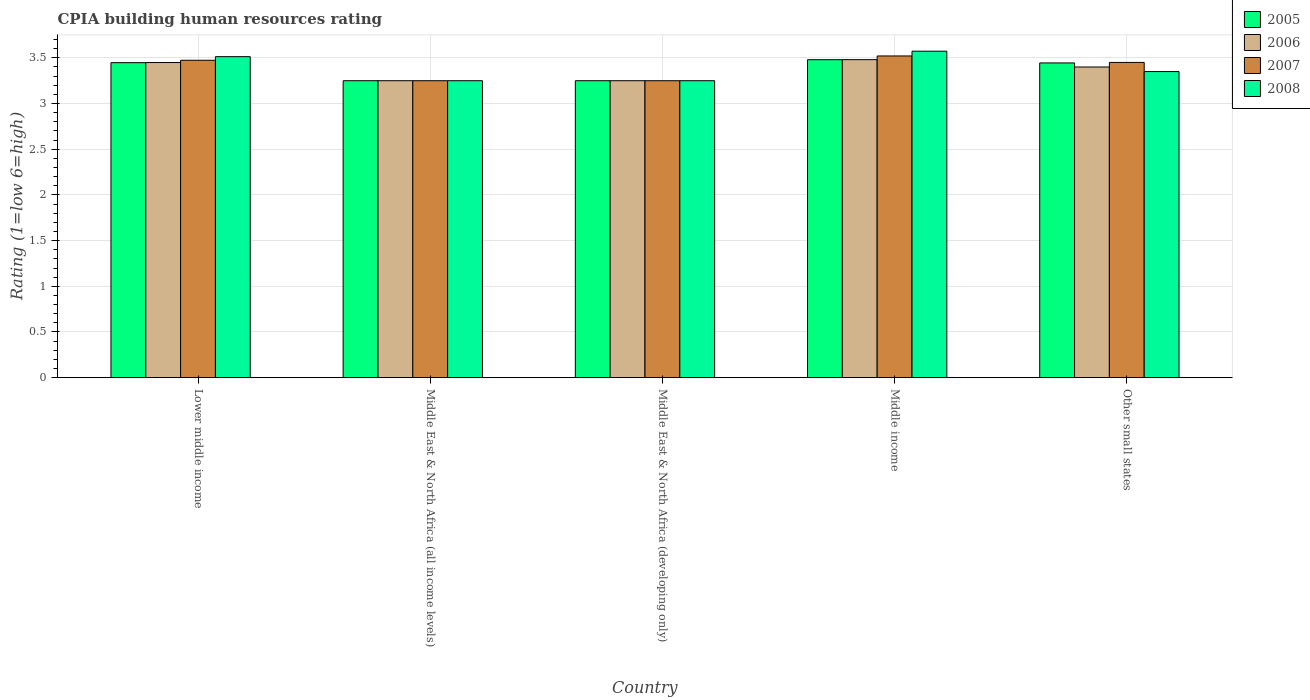How many different coloured bars are there?
Provide a short and direct response. 4. How many groups of bars are there?
Provide a succinct answer. 5. Are the number of bars per tick equal to the number of legend labels?
Offer a terse response. Yes. Are the number of bars on each tick of the X-axis equal?
Ensure brevity in your answer.  Yes. How many bars are there on the 4th tick from the left?
Your response must be concise. 4. How many bars are there on the 1st tick from the right?
Your response must be concise. 4. What is the label of the 1st group of bars from the left?
Give a very brief answer. Lower middle income. What is the CPIA rating in 2005 in Middle income?
Make the answer very short. 3.48. Across all countries, what is the maximum CPIA rating in 2007?
Make the answer very short. 3.52. Across all countries, what is the minimum CPIA rating in 2008?
Your response must be concise. 3.25. In which country was the CPIA rating in 2006 maximum?
Ensure brevity in your answer.  Middle income. In which country was the CPIA rating in 2006 minimum?
Your answer should be very brief. Middle East & North Africa (all income levels). What is the total CPIA rating in 2005 in the graph?
Ensure brevity in your answer.  16.87. What is the difference between the CPIA rating in 2005 in Middle income and that in Other small states?
Provide a short and direct response. 0.04. What is the difference between the CPIA rating in 2008 in Other small states and the CPIA rating in 2006 in Middle income?
Offer a very short reply. -0.13. What is the average CPIA rating in 2006 per country?
Give a very brief answer. 3.37. What is the difference between the CPIA rating of/in 2008 and CPIA rating of/in 2005 in Lower middle income?
Give a very brief answer. 0.07. What is the ratio of the CPIA rating in 2006 in Lower middle income to that in Middle East & North Africa (developing only)?
Your answer should be very brief. 1.06. Is the CPIA rating in 2008 in Middle East & North Africa (all income levels) less than that in Other small states?
Your answer should be compact. Yes. Is the difference between the CPIA rating in 2008 in Lower middle income and Middle East & North Africa (developing only) greater than the difference between the CPIA rating in 2005 in Lower middle income and Middle East & North Africa (developing only)?
Your response must be concise. Yes. What is the difference between the highest and the second highest CPIA rating in 2006?
Offer a very short reply. -0.03. What is the difference between the highest and the lowest CPIA rating in 2007?
Give a very brief answer. 0.27. What does the 1st bar from the right in Middle income represents?
Your answer should be very brief. 2008. How many bars are there?
Your answer should be compact. 20. Are all the bars in the graph horizontal?
Keep it short and to the point. No. How many countries are there in the graph?
Your answer should be very brief. 5. What is the difference between two consecutive major ticks on the Y-axis?
Give a very brief answer. 0.5. Are the values on the major ticks of Y-axis written in scientific E-notation?
Make the answer very short. No. Does the graph contain any zero values?
Your answer should be compact. No. Does the graph contain grids?
Your response must be concise. Yes. Where does the legend appear in the graph?
Your response must be concise. Top right. How many legend labels are there?
Provide a short and direct response. 4. How are the legend labels stacked?
Offer a terse response. Vertical. What is the title of the graph?
Your answer should be very brief. CPIA building human resources rating. What is the label or title of the Y-axis?
Your answer should be very brief. Rating (1=low 6=high). What is the Rating (1=low 6=high) of 2005 in Lower middle income?
Provide a short and direct response. 3.45. What is the Rating (1=low 6=high) of 2006 in Lower middle income?
Offer a terse response. 3.45. What is the Rating (1=low 6=high) in 2007 in Lower middle income?
Ensure brevity in your answer.  3.47. What is the Rating (1=low 6=high) in 2008 in Lower middle income?
Give a very brief answer. 3.51. What is the Rating (1=low 6=high) in 2005 in Middle East & North Africa (all income levels)?
Your answer should be very brief. 3.25. What is the Rating (1=low 6=high) in 2007 in Middle East & North Africa (all income levels)?
Keep it short and to the point. 3.25. What is the Rating (1=low 6=high) of 2008 in Middle East & North Africa (all income levels)?
Ensure brevity in your answer.  3.25. What is the Rating (1=low 6=high) in 2007 in Middle East & North Africa (developing only)?
Offer a terse response. 3.25. What is the Rating (1=low 6=high) of 2005 in Middle income?
Make the answer very short. 3.48. What is the Rating (1=low 6=high) of 2006 in Middle income?
Give a very brief answer. 3.48. What is the Rating (1=low 6=high) in 2007 in Middle income?
Your answer should be very brief. 3.52. What is the Rating (1=low 6=high) of 2008 in Middle income?
Provide a succinct answer. 3.57. What is the Rating (1=low 6=high) in 2005 in Other small states?
Offer a very short reply. 3.44. What is the Rating (1=low 6=high) of 2007 in Other small states?
Your answer should be compact. 3.45. What is the Rating (1=low 6=high) in 2008 in Other small states?
Ensure brevity in your answer.  3.35. Across all countries, what is the maximum Rating (1=low 6=high) in 2005?
Offer a very short reply. 3.48. Across all countries, what is the maximum Rating (1=low 6=high) in 2006?
Your answer should be compact. 3.48. Across all countries, what is the maximum Rating (1=low 6=high) in 2007?
Offer a very short reply. 3.52. Across all countries, what is the maximum Rating (1=low 6=high) of 2008?
Offer a very short reply. 3.57. Across all countries, what is the minimum Rating (1=low 6=high) in 2007?
Provide a short and direct response. 3.25. Across all countries, what is the minimum Rating (1=low 6=high) of 2008?
Offer a very short reply. 3.25. What is the total Rating (1=low 6=high) of 2005 in the graph?
Your response must be concise. 16.87. What is the total Rating (1=low 6=high) of 2006 in the graph?
Make the answer very short. 16.83. What is the total Rating (1=low 6=high) in 2007 in the graph?
Offer a terse response. 16.94. What is the total Rating (1=low 6=high) of 2008 in the graph?
Make the answer very short. 16.94. What is the difference between the Rating (1=low 6=high) of 2005 in Lower middle income and that in Middle East & North Africa (all income levels)?
Your answer should be very brief. 0.2. What is the difference between the Rating (1=low 6=high) of 2006 in Lower middle income and that in Middle East & North Africa (all income levels)?
Your answer should be very brief. 0.2. What is the difference between the Rating (1=low 6=high) of 2007 in Lower middle income and that in Middle East & North Africa (all income levels)?
Your response must be concise. 0.22. What is the difference between the Rating (1=low 6=high) of 2008 in Lower middle income and that in Middle East & North Africa (all income levels)?
Offer a very short reply. 0.26. What is the difference between the Rating (1=low 6=high) in 2005 in Lower middle income and that in Middle East & North Africa (developing only)?
Ensure brevity in your answer.  0.2. What is the difference between the Rating (1=low 6=high) in 2006 in Lower middle income and that in Middle East & North Africa (developing only)?
Your response must be concise. 0.2. What is the difference between the Rating (1=low 6=high) in 2007 in Lower middle income and that in Middle East & North Africa (developing only)?
Offer a terse response. 0.22. What is the difference between the Rating (1=low 6=high) of 2008 in Lower middle income and that in Middle East & North Africa (developing only)?
Provide a short and direct response. 0.26. What is the difference between the Rating (1=low 6=high) of 2005 in Lower middle income and that in Middle income?
Make the answer very short. -0.03. What is the difference between the Rating (1=low 6=high) in 2006 in Lower middle income and that in Middle income?
Offer a terse response. -0.03. What is the difference between the Rating (1=low 6=high) in 2007 in Lower middle income and that in Middle income?
Make the answer very short. -0.05. What is the difference between the Rating (1=low 6=high) of 2008 in Lower middle income and that in Middle income?
Make the answer very short. -0.06. What is the difference between the Rating (1=low 6=high) in 2005 in Lower middle income and that in Other small states?
Your answer should be compact. 0. What is the difference between the Rating (1=low 6=high) of 2006 in Lower middle income and that in Other small states?
Make the answer very short. 0.05. What is the difference between the Rating (1=low 6=high) in 2007 in Lower middle income and that in Other small states?
Offer a very short reply. 0.02. What is the difference between the Rating (1=low 6=high) of 2008 in Lower middle income and that in Other small states?
Offer a very short reply. 0.16. What is the difference between the Rating (1=low 6=high) in 2005 in Middle East & North Africa (all income levels) and that in Middle East & North Africa (developing only)?
Your answer should be compact. 0. What is the difference between the Rating (1=low 6=high) in 2007 in Middle East & North Africa (all income levels) and that in Middle East & North Africa (developing only)?
Your answer should be compact. 0. What is the difference between the Rating (1=low 6=high) of 2008 in Middle East & North Africa (all income levels) and that in Middle East & North Africa (developing only)?
Provide a short and direct response. 0. What is the difference between the Rating (1=low 6=high) in 2005 in Middle East & North Africa (all income levels) and that in Middle income?
Your answer should be compact. -0.23. What is the difference between the Rating (1=low 6=high) in 2006 in Middle East & North Africa (all income levels) and that in Middle income?
Ensure brevity in your answer.  -0.23. What is the difference between the Rating (1=low 6=high) in 2007 in Middle East & North Africa (all income levels) and that in Middle income?
Offer a very short reply. -0.27. What is the difference between the Rating (1=low 6=high) in 2008 in Middle East & North Africa (all income levels) and that in Middle income?
Ensure brevity in your answer.  -0.32. What is the difference between the Rating (1=low 6=high) in 2005 in Middle East & North Africa (all income levels) and that in Other small states?
Keep it short and to the point. -0.19. What is the difference between the Rating (1=low 6=high) in 2006 in Middle East & North Africa (all income levels) and that in Other small states?
Offer a terse response. -0.15. What is the difference between the Rating (1=low 6=high) of 2007 in Middle East & North Africa (all income levels) and that in Other small states?
Your response must be concise. -0.2. What is the difference between the Rating (1=low 6=high) in 2005 in Middle East & North Africa (developing only) and that in Middle income?
Ensure brevity in your answer.  -0.23. What is the difference between the Rating (1=low 6=high) in 2006 in Middle East & North Africa (developing only) and that in Middle income?
Give a very brief answer. -0.23. What is the difference between the Rating (1=low 6=high) in 2007 in Middle East & North Africa (developing only) and that in Middle income?
Make the answer very short. -0.27. What is the difference between the Rating (1=low 6=high) in 2008 in Middle East & North Africa (developing only) and that in Middle income?
Offer a terse response. -0.32. What is the difference between the Rating (1=low 6=high) in 2005 in Middle East & North Africa (developing only) and that in Other small states?
Provide a short and direct response. -0.19. What is the difference between the Rating (1=low 6=high) in 2005 in Middle income and that in Other small states?
Your answer should be compact. 0.04. What is the difference between the Rating (1=low 6=high) in 2006 in Middle income and that in Other small states?
Make the answer very short. 0.08. What is the difference between the Rating (1=low 6=high) of 2007 in Middle income and that in Other small states?
Your answer should be compact. 0.07. What is the difference between the Rating (1=low 6=high) in 2008 in Middle income and that in Other small states?
Give a very brief answer. 0.22. What is the difference between the Rating (1=low 6=high) of 2005 in Lower middle income and the Rating (1=low 6=high) of 2006 in Middle East & North Africa (all income levels)?
Offer a very short reply. 0.2. What is the difference between the Rating (1=low 6=high) in 2005 in Lower middle income and the Rating (1=low 6=high) in 2007 in Middle East & North Africa (all income levels)?
Keep it short and to the point. 0.2. What is the difference between the Rating (1=low 6=high) of 2005 in Lower middle income and the Rating (1=low 6=high) of 2008 in Middle East & North Africa (all income levels)?
Offer a terse response. 0.2. What is the difference between the Rating (1=low 6=high) in 2006 in Lower middle income and the Rating (1=low 6=high) in 2007 in Middle East & North Africa (all income levels)?
Provide a short and direct response. 0.2. What is the difference between the Rating (1=low 6=high) in 2006 in Lower middle income and the Rating (1=low 6=high) in 2008 in Middle East & North Africa (all income levels)?
Ensure brevity in your answer.  0.2. What is the difference between the Rating (1=low 6=high) of 2007 in Lower middle income and the Rating (1=low 6=high) of 2008 in Middle East & North Africa (all income levels)?
Your response must be concise. 0.22. What is the difference between the Rating (1=low 6=high) in 2005 in Lower middle income and the Rating (1=low 6=high) in 2006 in Middle East & North Africa (developing only)?
Keep it short and to the point. 0.2. What is the difference between the Rating (1=low 6=high) in 2005 in Lower middle income and the Rating (1=low 6=high) in 2007 in Middle East & North Africa (developing only)?
Offer a terse response. 0.2. What is the difference between the Rating (1=low 6=high) of 2005 in Lower middle income and the Rating (1=low 6=high) of 2008 in Middle East & North Africa (developing only)?
Make the answer very short. 0.2. What is the difference between the Rating (1=low 6=high) in 2006 in Lower middle income and the Rating (1=low 6=high) in 2007 in Middle East & North Africa (developing only)?
Your answer should be very brief. 0.2. What is the difference between the Rating (1=low 6=high) of 2006 in Lower middle income and the Rating (1=low 6=high) of 2008 in Middle East & North Africa (developing only)?
Ensure brevity in your answer.  0.2. What is the difference between the Rating (1=low 6=high) in 2007 in Lower middle income and the Rating (1=low 6=high) in 2008 in Middle East & North Africa (developing only)?
Provide a short and direct response. 0.22. What is the difference between the Rating (1=low 6=high) of 2005 in Lower middle income and the Rating (1=low 6=high) of 2006 in Middle income?
Offer a very short reply. -0.03. What is the difference between the Rating (1=low 6=high) of 2005 in Lower middle income and the Rating (1=low 6=high) of 2007 in Middle income?
Your answer should be very brief. -0.07. What is the difference between the Rating (1=low 6=high) in 2005 in Lower middle income and the Rating (1=low 6=high) in 2008 in Middle income?
Keep it short and to the point. -0.13. What is the difference between the Rating (1=low 6=high) in 2006 in Lower middle income and the Rating (1=low 6=high) in 2007 in Middle income?
Your answer should be compact. -0.07. What is the difference between the Rating (1=low 6=high) in 2006 in Lower middle income and the Rating (1=low 6=high) in 2008 in Middle income?
Give a very brief answer. -0.12. What is the difference between the Rating (1=low 6=high) of 2007 in Lower middle income and the Rating (1=low 6=high) of 2008 in Middle income?
Your answer should be very brief. -0.1. What is the difference between the Rating (1=low 6=high) of 2005 in Lower middle income and the Rating (1=low 6=high) of 2006 in Other small states?
Provide a succinct answer. 0.05. What is the difference between the Rating (1=low 6=high) in 2005 in Lower middle income and the Rating (1=low 6=high) in 2007 in Other small states?
Your answer should be compact. -0. What is the difference between the Rating (1=low 6=high) of 2005 in Lower middle income and the Rating (1=low 6=high) of 2008 in Other small states?
Offer a very short reply. 0.1. What is the difference between the Rating (1=low 6=high) in 2006 in Lower middle income and the Rating (1=low 6=high) in 2007 in Other small states?
Give a very brief answer. -0. What is the difference between the Rating (1=low 6=high) in 2006 in Lower middle income and the Rating (1=low 6=high) in 2008 in Other small states?
Your answer should be compact. 0.1. What is the difference between the Rating (1=low 6=high) of 2007 in Lower middle income and the Rating (1=low 6=high) of 2008 in Other small states?
Your answer should be very brief. 0.12. What is the difference between the Rating (1=low 6=high) in 2006 in Middle East & North Africa (all income levels) and the Rating (1=low 6=high) in 2007 in Middle East & North Africa (developing only)?
Your response must be concise. 0. What is the difference between the Rating (1=low 6=high) of 2005 in Middle East & North Africa (all income levels) and the Rating (1=low 6=high) of 2006 in Middle income?
Keep it short and to the point. -0.23. What is the difference between the Rating (1=low 6=high) in 2005 in Middle East & North Africa (all income levels) and the Rating (1=low 6=high) in 2007 in Middle income?
Provide a succinct answer. -0.27. What is the difference between the Rating (1=low 6=high) in 2005 in Middle East & North Africa (all income levels) and the Rating (1=low 6=high) in 2008 in Middle income?
Keep it short and to the point. -0.32. What is the difference between the Rating (1=low 6=high) of 2006 in Middle East & North Africa (all income levels) and the Rating (1=low 6=high) of 2007 in Middle income?
Provide a short and direct response. -0.27. What is the difference between the Rating (1=low 6=high) of 2006 in Middle East & North Africa (all income levels) and the Rating (1=low 6=high) of 2008 in Middle income?
Offer a very short reply. -0.32. What is the difference between the Rating (1=low 6=high) of 2007 in Middle East & North Africa (all income levels) and the Rating (1=low 6=high) of 2008 in Middle income?
Give a very brief answer. -0.32. What is the difference between the Rating (1=low 6=high) of 2005 in Middle East & North Africa (all income levels) and the Rating (1=low 6=high) of 2006 in Other small states?
Make the answer very short. -0.15. What is the difference between the Rating (1=low 6=high) of 2005 in Middle East & North Africa (all income levels) and the Rating (1=low 6=high) of 2008 in Other small states?
Keep it short and to the point. -0.1. What is the difference between the Rating (1=low 6=high) in 2006 in Middle East & North Africa (all income levels) and the Rating (1=low 6=high) in 2007 in Other small states?
Keep it short and to the point. -0.2. What is the difference between the Rating (1=low 6=high) of 2006 in Middle East & North Africa (all income levels) and the Rating (1=low 6=high) of 2008 in Other small states?
Provide a succinct answer. -0.1. What is the difference between the Rating (1=low 6=high) of 2005 in Middle East & North Africa (developing only) and the Rating (1=low 6=high) of 2006 in Middle income?
Provide a short and direct response. -0.23. What is the difference between the Rating (1=low 6=high) in 2005 in Middle East & North Africa (developing only) and the Rating (1=low 6=high) in 2007 in Middle income?
Your answer should be very brief. -0.27. What is the difference between the Rating (1=low 6=high) of 2005 in Middle East & North Africa (developing only) and the Rating (1=low 6=high) of 2008 in Middle income?
Ensure brevity in your answer.  -0.32. What is the difference between the Rating (1=low 6=high) in 2006 in Middle East & North Africa (developing only) and the Rating (1=low 6=high) in 2007 in Middle income?
Provide a succinct answer. -0.27. What is the difference between the Rating (1=low 6=high) in 2006 in Middle East & North Africa (developing only) and the Rating (1=low 6=high) in 2008 in Middle income?
Your answer should be compact. -0.32. What is the difference between the Rating (1=low 6=high) in 2007 in Middle East & North Africa (developing only) and the Rating (1=low 6=high) in 2008 in Middle income?
Provide a succinct answer. -0.32. What is the difference between the Rating (1=low 6=high) in 2005 in Middle East & North Africa (developing only) and the Rating (1=low 6=high) in 2006 in Other small states?
Your response must be concise. -0.15. What is the difference between the Rating (1=low 6=high) of 2005 in Middle East & North Africa (developing only) and the Rating (1=low 6=high) of 2007 in Other small states?
Make the answer very short. -0.2. What is the difference between the Rating (1=low 6=high) of 2005 in Middle income and the Rating (1=low 6=high) of 2006 in Other small states?
Offer a terse response. 0.08. What is the difference between the Rating (1=low 6=high) of 2005 in Middle income and the Rating (1=low 6=high) of 2007 in Other small states?
Offer a terse response. 0.03. What is the difference between the Rating (1=low 6=high) in 2005 in Middle income and the Rating (1=low 6=high) in 2008 in Other small states?
Offer a terse response. 0.13. What is the difference between the Rating (1=low 6=high) of 2006 in Middle income and the Rating (1=low 6=high) of 2007 in Other small states?
Make the answer very short. 0.03. What is the difference between the Rating (1=low 6=high) of 2006 in Middle income and the Rating (1=low 6=high) of 2008 in Other small states?
Your answer should be very brief. 0.13. What is the difference between the Rating (1=low 6=high) in 2007 in Middle income and the Rating (1=low 6=high) in 2008 in Other small states?
Your response must be concise. 0.17. What is the average Rating (1=low 6=high) of 2005 per country?
Provide a short and direct response. 3.37. What is the average Rating (1=low 6=high) of 2006 per country?
Offer a terse response. 3.37. What is the average Rating (1=low 6=high) in 2007 per country?
Your answer should be very brief. 3.39. What is the average Rating (1=low 6=high) of 2008 per country?
Keep it short and to the point. 3.39. What is the difference between the Rating (1=low 6=high) of 2005 and Rating (1=low 6=high) of 2006 in Lower middle income?
Your answer should be very brief. -0. What is the difference between the Rating (1=low 6=high) in 2005 and Rating (1=low 6=high) in 2007 in Lower middle income?
Your answer should be compact. -0.03. What is the difference between the Rating (1=low 6=high) of 2005 and Rating (1=low 6=high) of 2008 in Lower middle income?
Your response must be concise. -0.07. What is the difference between the Rating (1=low 6=high) of 2006 and Rating (1=low 6=high) of 2007 in Lower middle income?
Make the answer very short. -0.03. What is the difference between the Rating (1=low 6=high) of 2006 and Rating (1=low 6=high) of 2008 in Lower middle income?
Give a very brief answer. -0.06. What is the difference between the Rating (1=low 6=high) in 2007 and Rating (1=low 6=high) in 2008 in Lower middle income?
Provide a short and direct response. -0.04. What is the difference between the Rating (1=low 6=high) of 2005 and Rating (1=low 6=high) of 2006 in Middle East & North Africa (all income levels)?
Make the answer very short. 0. What is the difference between the Rating (1=low 6=high) of 2005 and Rating (1=low 6=high) of 2007 in Middle East & North Africa (all income levels)?
Your response must be concise. 0. What is the difference between the Rating (1=low 6=high) of 2005 and Rating (1=low 6=high) of 2008 in Middle East & North Africa (all income levels)?
Offer a terse response. 0. What is the difference between the Rating (1=low 6=high) in 2006 and Rating (1=low 6=high) in 2007 in Middle East & North Africa (all income levels)?
Offer a terse response. 0. What is the difference between the Rating (1=low 6=high) of 2006 and Rating (1=low 6=high) of 2007 in Middle East & North Africa (developing only)?
Make the answer very short. 0. What is the difference between the Rating (1=low 6=high) in 2006 and Rating (1=low 6=high) in 2008 in Middle East & North Africa (developing only)?
Make the answer very short. 0. What is the difference between the Rating (1=low 6=high) in 2007 and Rating (1=low 6=high) in 2008 in Middle East & North Africa (developing only)?
Offer a terse response. 0. What is the difference between the Rating (1=low 6=high) in 2005 and Rating (1=low 6=high) in 2006 in Middle income?
Offer a very short reply. -0. What is the difference between the Rating (1=low 6=high) of 2005 and Rating (1=low 6=high) of 2007 in Middle income?
Ensure brevity in your answer.  -0.04. What is the difference between the Rating (1=low 6=high) of 2005 and Rating (1=low 6=high) of 2008 in Middle income?
Your answer should be compact. -0.09. What is the difference between the Rating (1=low 6=high) of 2006 and Rating (1=low 6=high) of 2007 in Middle income?
Your answer should be compact. -0.04. What is the difference between the Rating (1=low 6=high) of 2006 and Rating (1=low 6=high) of 2008 in Middle income?
Keep it short and to the point. -0.09. What is the difference between the Rating (1=low 6=high) of 2007 and Rating (1=low 6=high) of 2008 in Middle income?
Offer a very short reply. -0.05. What is the difference between the Rating (1=low 6=high) of 2005 and Rating (1=low 6=high) of 2006 in Other small states?
Ensure brevity in your answer.  0.04. What is the difference between the Rating (1=low 6=high) of 2005 and Rating (1=low 6=high) of 2007 in Other small states?
Ensure brevity in your answer.  -0.01. What is the difference between the Rating (1=low 6=high) of 2005 and Rating (1=low 6=high) of 2008 in Other small states?
Offer a terse response. 0.09. What is the difference between the Rating (1=low 6=high) of 2006 and Rating (1=low 6=high) of 2008 in Other small states?
Provide a short and direct response. 0.05. What is the difference between the Rating (1=low 6=high) in 2007 and Rating (1=low 6=high) in 2008 in Other small states?
Your answer should be compact. 0.1. What is the ratio of the Rating (1=low 6=high) of 2005 in Lower middle income to that in Middle East & North Africa (all income levels)?
Your answer should be very brief. 1.06. What is the ratio of the Rating (1=low 6=high) of 2006 in Lower middle income to that in Middle East & North Africa (all income levels)?
Keep it short and to the point. 1.06. What is the ratio of the Rating (1=low 6=high) in 2007 in Lower middle income to that in Middle East & North Africa (all income levels)?
Give a very brief answer. 1.07. What is the ratio of the Rating (1=low 6=high) of 2008 in Lower middle income to that in Middle East & North Africa (all income levels)?
Give a very brief answer. 1.08. What is the ratio of the Rating (1=low 6=high) of 2005 in Lower middle income to that in Middle East & North Africa (developing only)?
Offer a very short reply. 1.06. What is the ratio of the Rating (1=low 6=high) in 2006 in Lower middle income to that in Middle East & North Africa (developing only)?
Provide a short and direct response. 1.06. What is the ratio of the Rating (1=low 6=high) in 2007 in Lower middle income to that in Middle East & North Africa (developing only)?
Your response must be concise. 1.07. What is the ratio of the Rating (1=low 6=high) in 2008 in Lower middle income to that in Middle East & North Africa (developing only)?
Offer a very short reply. 1.08. What is the ratio of the Rating (1=low 6=high) in 2005 in Lower middle income to that in Middle income?
Make the answer very short. 0.99. What is the ratio of the Rating (1=low 6=high) of 2006 in Lower middle income to that in Middle income?
Give a very brief answer. 0.99. What is the ratio of the Rating (1=low 6=high) of 2007 in Lower middle income to that in Middle income?
Your answer should be very brief. 0.99. What is the ratio of the Rating (1=low 6=high) in 2008 in Lower middle income to that in Middle income?
Make the answer very short. 0.98. What is the ratio of the Rating (1=low 6=high) of 2006 in Lower middle income to that in Other small states?
Ensure brevity in your answer.  1.01. What is the ratio of the Rating (1=low 6=high) of 2007 in Lower middle income to that in Other small states?
Offer a terse response. 1.01. What is the ratio of the Rating (1=low 6=high) in 2008 in Lower middle income to that in Other small states?
Offer a very short reply. 1.05. What is the ratio of the Rating (1=low 6=high) of 2005 in Middle East & North Africa (all income levels) to that in Middle East & North Africa (developing only)?
Provide a succinct answer. 1. What is the ratio of the Rating (1=low 6=high) in 2006 in Middle East & North Africa (all income levels) to that in Middle East & North Africa (developing only)?
Provide a succinct answer. 1. What is the ratio of the Rating (1=low 6=high) of 2007 in Middle East & North Africa (all income levels) to that in Middle East & North Africa (developing only)?
Offer a terse response. 1. What is the ratio of the Rating (1=low 6=high) of 2005 in Middle East & North Africa (all income levels) to that in Middle income?
Provide a succinct answer. 0.93. What is the ratio of the Rating (1=low 6=high) in 2006 in Middle East & North Africa (all income levels) to that in Middle income?
Your answer should be compact. 0.93. What is the ratio of the Rating (1=low 6=high) in 2008 in Middle East & North Africa (all income levels) to that in Middle income?
Ensure brevity in your answer.  0.91. What is the ratio of the Rating (1=low 6=high) in 2005 in Middle East & North Africa (all income levels) to that in Other small states?
Offer a very short reply. 0.94. What is the ratio of the Rating (1=low 6=high) of 2006 in Middle East & North Africa (all income levels) to that in Other small states?
Give a very brief answer. 0.96. What is the ratio of the Rating (1=low 6=high) of 2007 in Middle East & North Africa (all income levels) to that in Other small states?
Provide a succinct answer. 0.94. What is the ratio of the Rating (1=low 6=high) of 2008 in Middle East & North Africa (all income levels) to that in Other small states?
Your response must be concise. 0.97. What is the ratio of the Rating (1=low 6=high) of 2005 in Middle East & North Africa (developing only) to that in Middle income?
Your answer should be very brief. 0.93. What is the ratio of the Rating (1=low 6=high) of 2006 in Middle East & North Africa (developing only) to that in Middle income?
Keep it short and to the point. 0.93. What is the ratio of the Rating (1=low 6=high) in 2007 in Middle East & North Africa (developing only) to that in Middle income?
Give a very brief answer. 0.92. What is the ratio of the Rating (1=low 6=high) of 2008 in Middle East & North Africa (developing only) to that in Middle income?
Give a very brief answer. 0.91. What is the ratio of the Rating (1=low 6=high) of 2005 in Middle East & North Africa (developing only) to that in Other small states?
Your answer should be compact. 0.94. What is the ratio of the Rating (1=low 6=high) of 2006 in Middle East & North Africa (developing only) to that in Other small states?
Provide a short and direct response. 0.96. What is the ratio of the Rating (1=low 6=high) of 2007 in Middle East & North Africa (developing only) to that in Other small states?
Your answer should be compact. 0.94. What is the ratio of the Rating (1=low 6=high) in 2008 in Middle East & North Africa (developing only) to that in Other small states?
Give a very brief answer. 0.97. What is the ratio of the Rating (1=low 6=high) in 2005 in Middle income to that in Other small states?
Provide a succinct answer. 1.01. What is the ratio of the Rating (1=low 6=high) in 2006 in Middle income to that in Other small states?
Give a very brief answer. 1.02. What is the ratio of the Rating (1=low 6=high) in 2007 in Middle income to that in Other small states?
Provide a succinct answer. 1.02. What is the ratio of the Rating (1=low 6=high) of 2008 in Middle income to that in Other small states?
Your response must be concise. 1.07. What is the difference between the highest and the second highest Rating (1=low 6=high) of 2005?
Give a very brief answer. 0.03. What is the difference between the highest and the second highest Rating (1=low 6=high) in 2006?
Your answer should be very brief. 0.03. What is the difference between the highest and the second highest Rating (1=low 6=high) of 2007?
Your response must be concise. 0.05. What is the difference between the highest and the second highest Rating (1=low 6=high) in 2008?
Ensure brevity in your answer.  0.06. What is the difference between the highest and the lowest Rating (1=low 6=high) in 2005?
Give a very brief answer. 0.23. What is the difference between the highest and the lowest Rating (1=low 6=high) in 2006?
Provide a succinct answer. 0.23. What is the difference between the highest and the lowest Rating (1=low 6=high) of 2007?
Your answer should be very brief. 0.27. What is the difference between the highest and the lowest Rating (1=low 6=high) of 2008?
Ensure brevity in your answer.  0.32. 